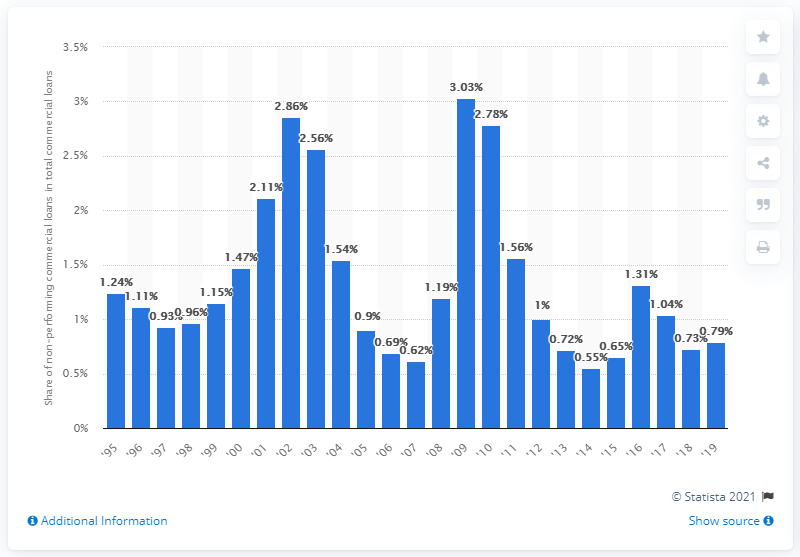Indicate a few pertinent items in this graphic. In 2019, non-performing loans accounted for 0.79% of total U.S. commercial loans. 